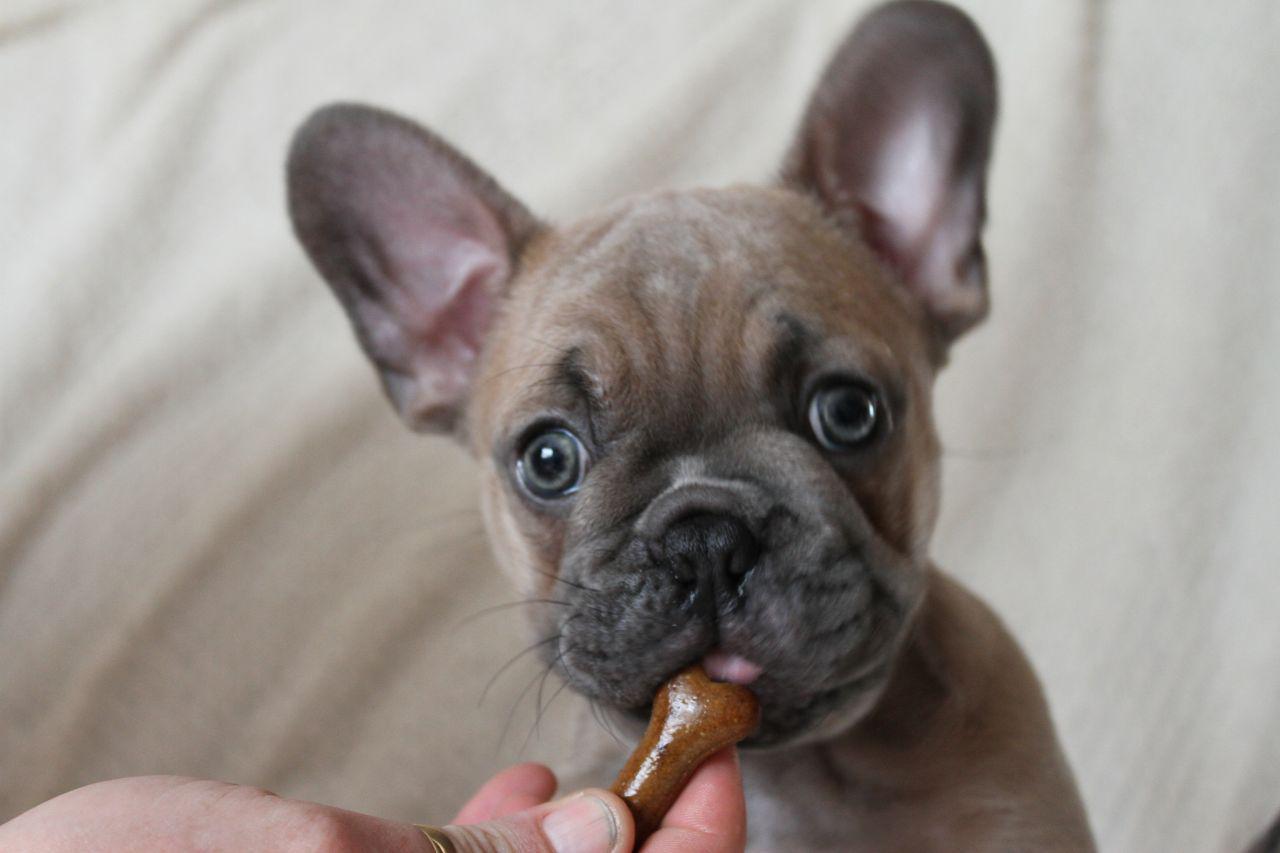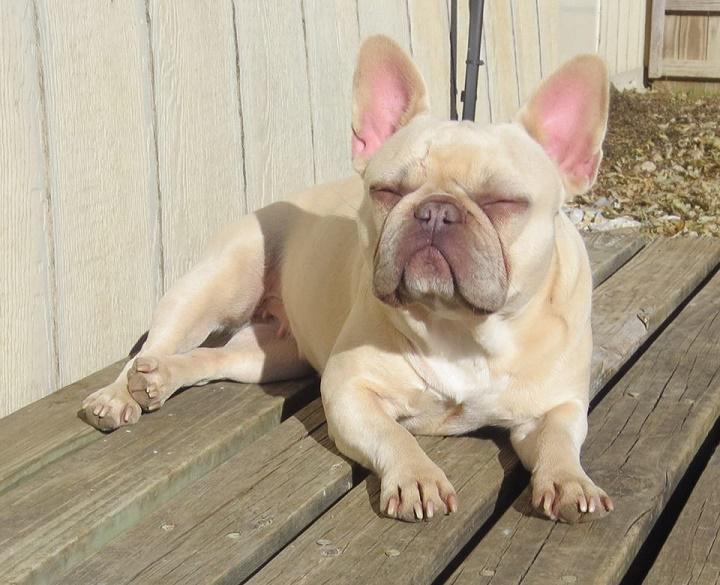The first image is the image on the left, the second image is the image on the right. For the images shown, is this caption "Each image shows one dog standing on all fours, and one image shows a dog standing with its body in profile." true? Answer yes or no. No. The first image is the image on the left, the second image is the image on the right. Assess this claim about the two images: "One dog is wearing something around his neck.". Correct or not? Answer yes or no. No. 